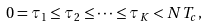<formula> <loc_0><loc_0><loc_500><loc_500>0 = \tau _ { 1 } \leq \tau _ { 2 } \leq \cdots \leq \tau _ { K } < N T _ { c } ,</formula> 